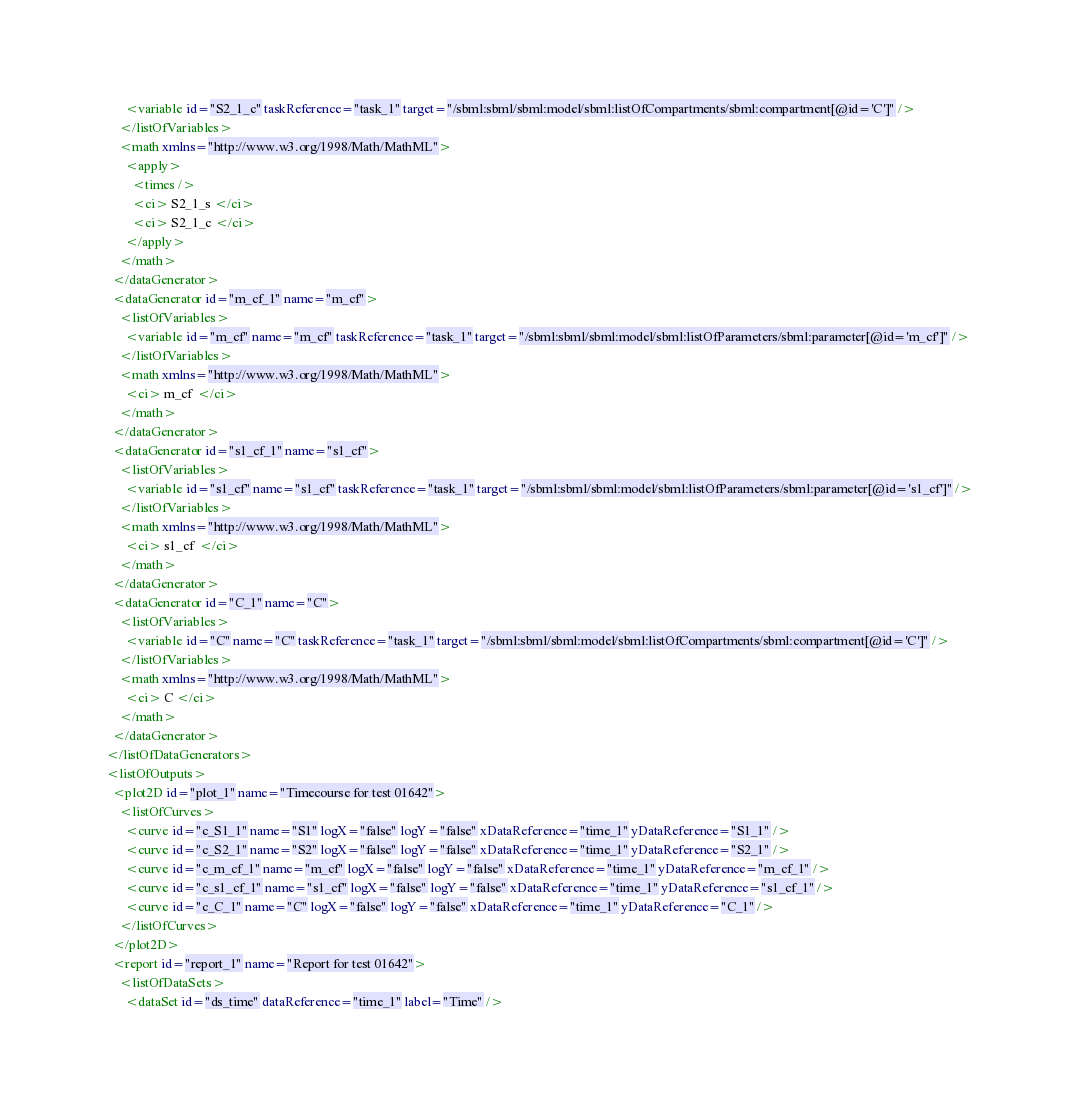<code> <loc_0><loc_0><loc_500><loc_500><_XML_>        <variable id="S2_1_c" taskReference="task_1" target="/sbml:sbml/sbml:model/sbml:listOfCompartments/sbml:compartment[@id='C']" />
      </listOfVariables>
      <math xmlns="http://www.w3.org/1998/Math/MathML">
        <apply>
          <times />
          <ci> S2_1_s </ci>
          <ci> S2_1_c </ci>
        </apply>
      </math>
    </dataGenerator>
    <dataGenerator id="m_cf_1" name="m_cf">
      <listOfVariables>
        <variable id="m_cf" name="m_cf" taskReference="task_1" target="/sbml:sbml/sbml:model/sbml:listOfParameters/sbml:parameter[@id='m_cf']" />
      </listOfVariables>
      <math xmlns="http://www.w3.org/1998/Math/MathML">
        <ci> m_cf </ci>
      </math>
    </dataGenerator>
    <dataGenerator id="s1_cf_1" name="s1_cf">
      <listOfVariables>
        <variable id="s1_cf" name="s1_cf" taskReference="task_1" target="/sbml:sbml/sbml:model/sbml:listOfParameters/sbml:parameter[@id='s1_cf']" />
      </listOfVariables>
      <math xmlns="http://www.w3.org/1998/Math/MathML">
        <ci> s1_cf </ci>
      </math>
    </dataGenerator>
    <dataGenerator id="C_1" name="C">
      <listOfVariables>
        <variable id="C" name="C" taskReference="task_1" target="/sbml:sbml/sbml:model/sbml:listOfCompartments/sbml:compartment[@id='C']" />
      </listOfVariables>
      <math xmlns="http://www.w3.org/1998/Math/MathML">
        <ci> C </ci>
      </math>
    </dataGenerator>
  </listOfDataGenerators>
  <listOfOutputs>
    <plot2D id="plot_1" name="Timecourse for test 01642">
      <listOfCurves>
        <curve id="c_S1_1" name="S1" logX="false" logY="false" xDataReference="time_1" yDataReference="S1_1" />
        <curve id="c_S2_1" name="S2" logX="false" logY="false" xDataReference="time_1" yDataReference="S2_1" />
        <curve id="c_m_cf_1" name="m_cf" logX="false" logY="false" xDataReference="time_1" yDataReference="m_cf_1" />
        <curve id="c_s1_cf_1" name="s1_cf" logX="false" logY="false" xDataReference="time_1" yDataReference="s1_cf_1" />
        <curve id="c_C_1" name="C" logX="false" logY="false" xDataReference="time_1" yDataReference="C_1" />
      </listOfCurves>
    </plot2D>
    <report id="report_1" name="Report for test 01642">
      <listOfDataSets>
        <dataSet id="ds_time" dataReference="time_1" label="Time" /></code> 